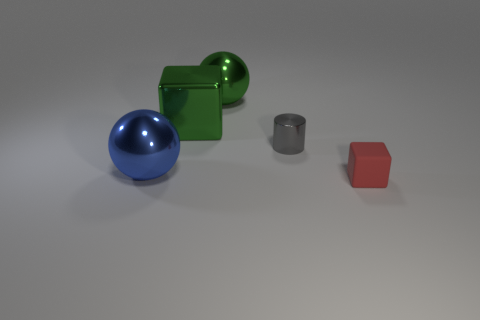Could you describe the positions of the objects relative to each other? Certainly! At the center, we have a blue sphere. To the left of this sphere, there's a green cube, and to the right, there's a smaller, gray cylinder. Further to the right, there's a smaller red cube, creating a roughly diagonal line of objects. 